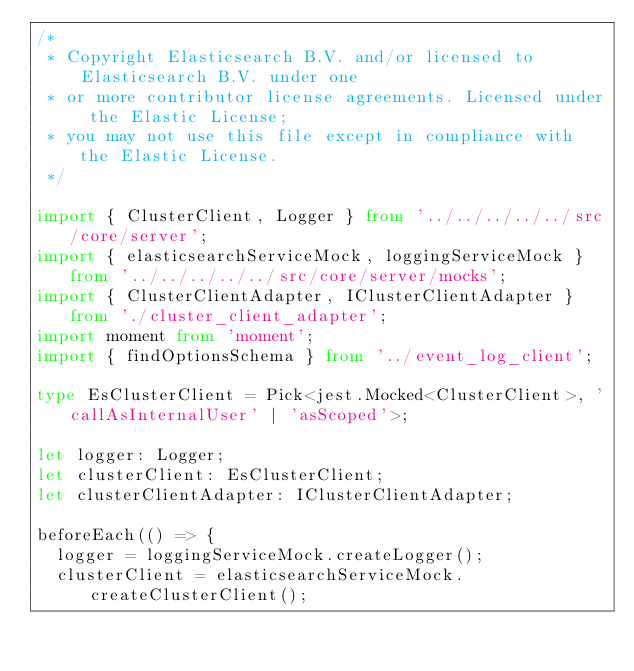Convert code to text. <code><loc_0><loc_0><loc_500><loc_500><_TypeScript_>/*
 * Copyright Elasticsearch B.V. and/or licensed to Elasticsearch B.V. under one
 * or more contributor license agreements. Licensed under the Elastic License;
 * you may not use this file except in compliance with the Elastic License.
 */

import { ClusterClient, Logger } from '../../../../../src/core/server';
import { elasticsearchServiceMock, loggingServiceMock } from '../../../../../src/core/server/mocks';
import { ClusterClientAdapter, IClusterClientAdapter } from './cluster_client_adapter';
import moment from 'moment';
import { findOptionsSchema } from '../event_log_client';

type EsClusterClient = Pick<jest.Mocked<ClusterClient>, 'callAsInternalUser' | 'asScoped'>;

let logger: Logger;
let clusterClient: EsClusterClient;
let clusterClientAdapter: IClusterClientAdapter;

beforeEach(() => {
  logger = loggingServiceMock.createLogger();
  clusterClient = elasticsearchServiceMock.createClusterClient();</code> 